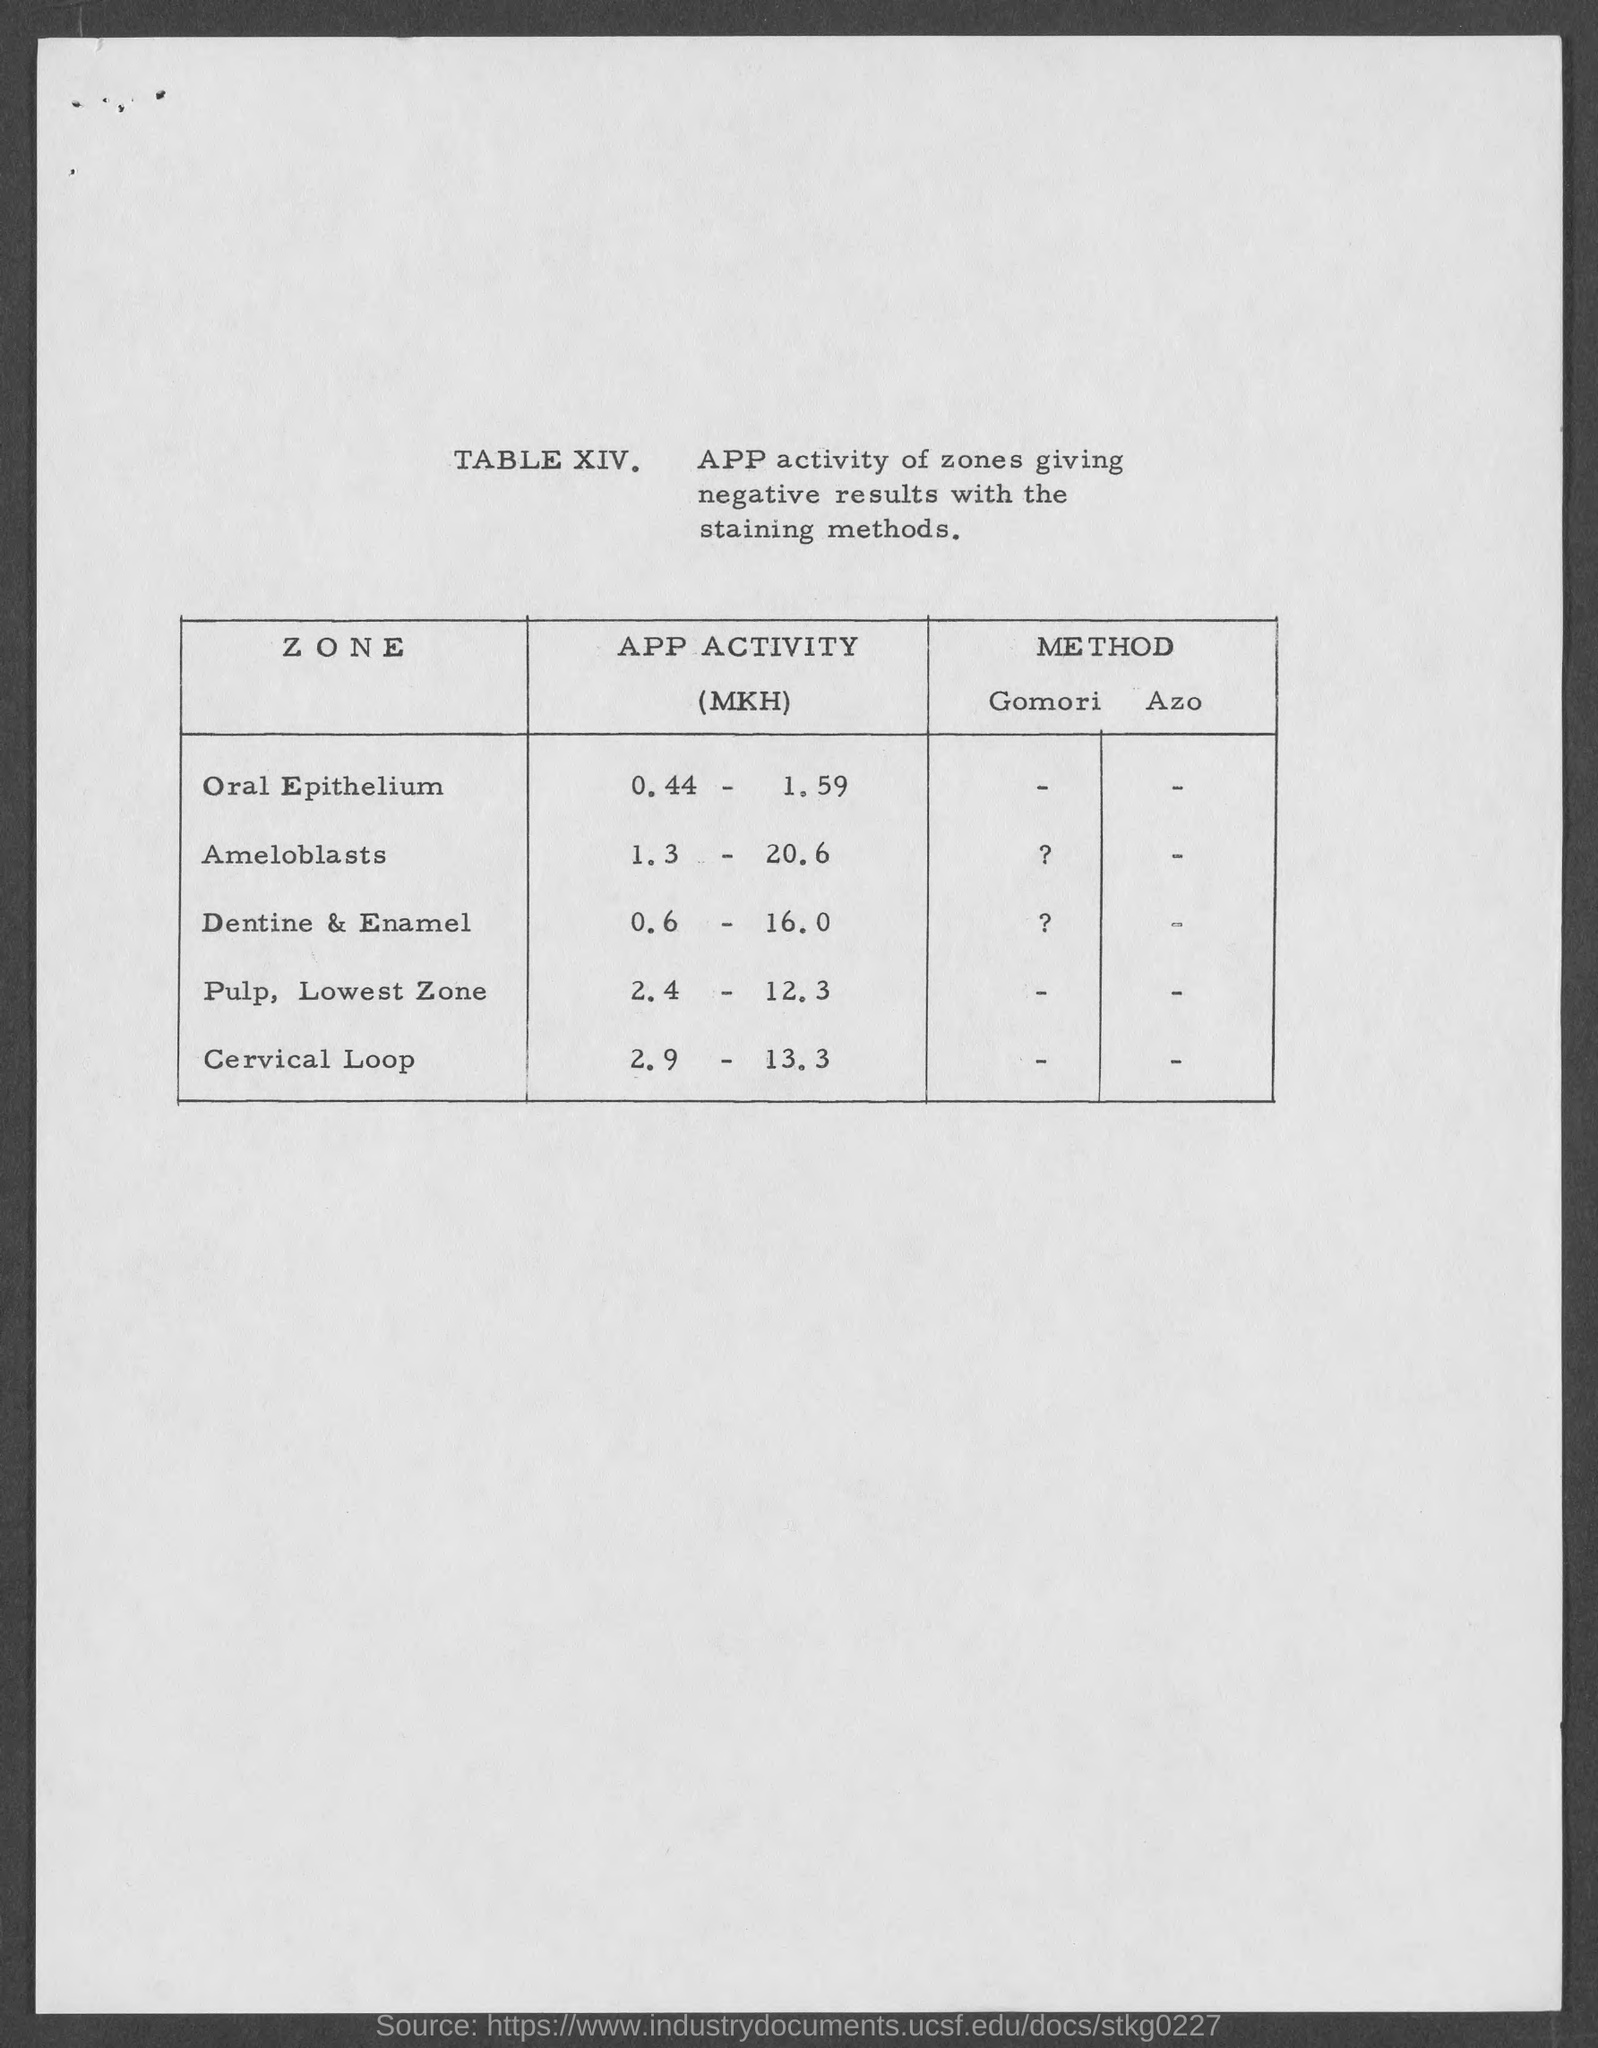Give some essential details in this illustration. The APP activity for the Cervical Loop zone is 2.9 to 13.3. The APP activity for Oral Epithelium zone is between 0.44 and 1.59. The APP activity for dentine and enamel zones is reported to be within the range of 0.6 to 16.0. The APP activity for pulp in the Lowest Zone is between 2.4 and 12.3. The activity of ameloblasts in the tooth-forming process ranges from zone 1.3 to 20.6. 